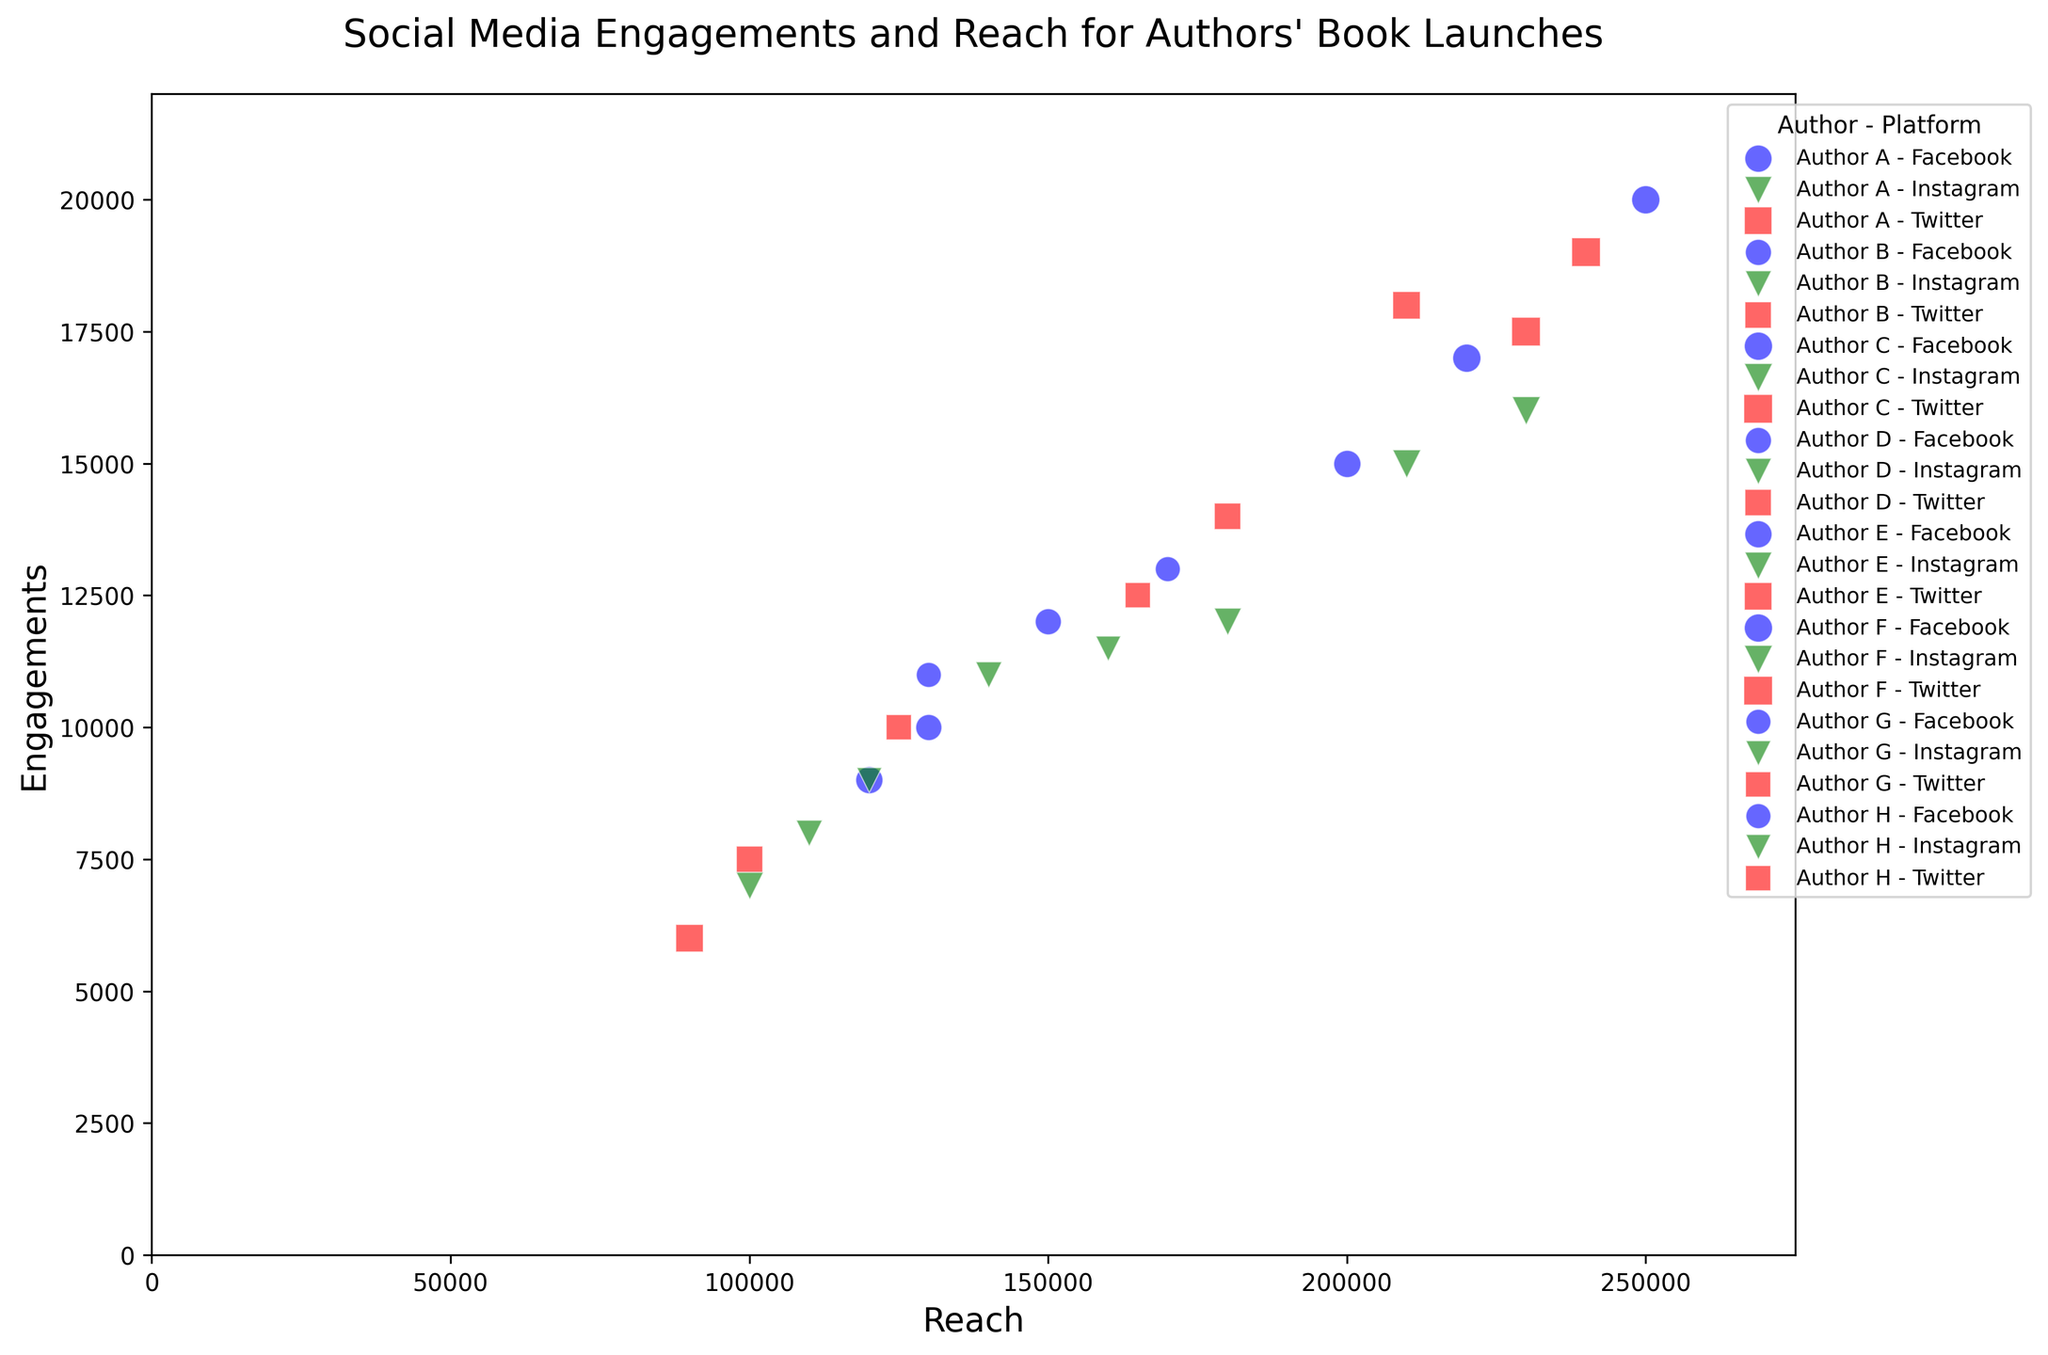Which author has the highest engagements on Facebook? To find the author with the highest engagements on Facebook, look at the points labeled with the Facebook platform color and find the one positioned highest on the engagements axis. Author C has the highest engagements on Facebook, with a value of 20,000.
Answer: Author C Which platform had the lowest reach for Author E? Isolate the points corresponding to Author E. Then compare the reach values for Facebook, Instagram, and Twitter platforms. The Twitter platform has the lowest reach for Author E, with a value of 90,000.
Answer: Twitter What is the difference in engagements between Author A and Author F on Instagram? Find the engagement values for both Author A and Author F on Instagram. Author A has 12,000 engagements, and Author F has 15,000 engagements. The difference is 15,000 - 12,000 = 3,000.
Answer: 3,000 How do the reach values of Author B on Facebook and Twitter compare? Look at the reach values for Author B on both Facebook and Twitter. For Facebook, it is 130,000, and for Twitter, it is 100,000. Facebook has a higher reach than Twitter for Author B.
Answer: Facebook Which author has the most books launched, and how many? Identify the size of the markers in the plot; the size is proportional to the number of books launched. Author C and Author F have the largest markers, representing 4 books each.
Answer: Author C and Author F, 4 each Which platform shows a greater range of engagement values across all authors? Compare the spread of engagement values (vertical axis) for each platform color across all authors. The Twitter platform shows a more extensive range of engagement values, from 6,000 to 19,5000.
Answer: Twitter What is the total reach for Author G across all platforms? Sum the reach values for Author G's Facebook, Instagram, and Twitter platforms (130,000 + 120,000 + 125,000). The total reach is 375,000.
Answer: 375,000 Which author has the closest engagement values across all three platforms? Calculate the engagement range for each author across their three platforms and compare them. Author H has engagements of 13,000, 11,500, and 12,500, which are close to each other, with a range of 13,000 - 11,500 = 1,500.
Answer: Author H 